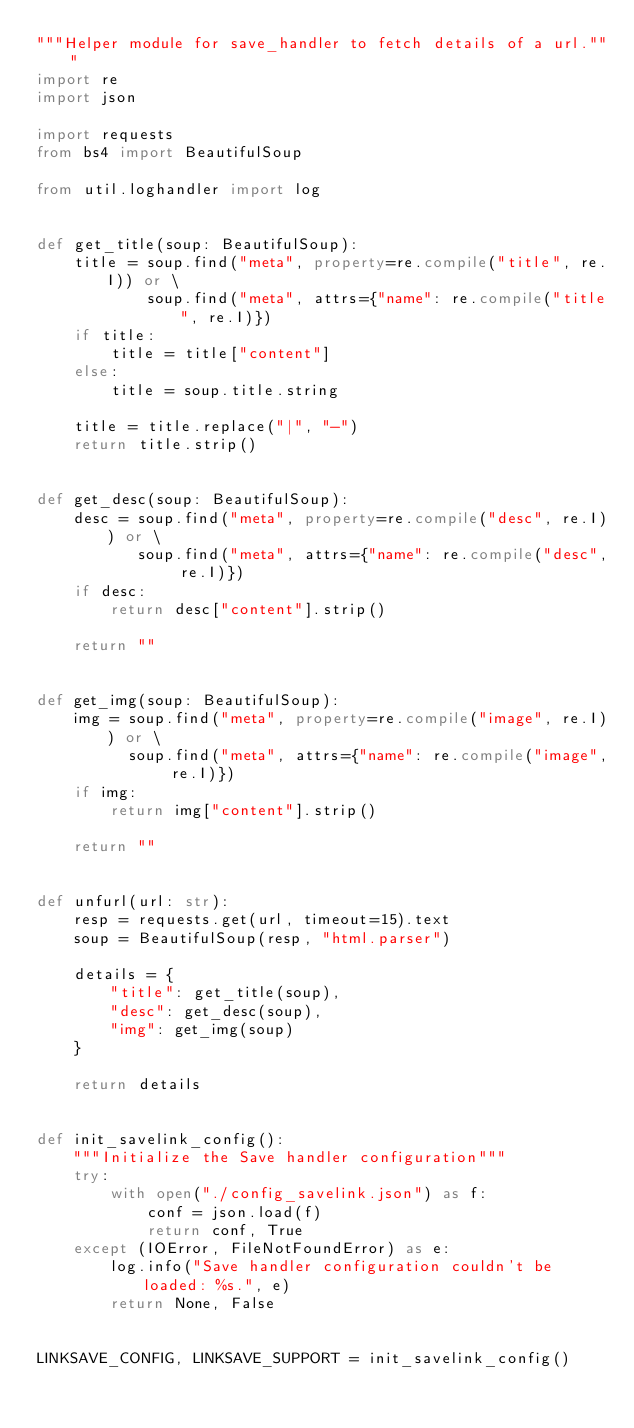Convert code to text. <code><loc_0><loc_0><loc_500><loc_500><_Python_>"""Helper module for save_handler to fetch details of a url."""
import re
import json

import requests
from bs4 import BeautifulSoup

from util.loghandler import log


def get_title(soup: BeautifulSoup):
    title = soup.find("meta", property=re.compile("title", re.I)) or \
            soup.find("meta", attrs={"name": re.compile("title", re.I)})
    if title:
        title = title["content"]
    else:
        title = soup.title.string

    title = title.replace("|", "-")
    return title.strip()


def get_desc(soup: BeautifulSoup):
    desc = soup.find("meta", property=re.compile("desc", re.I)) or \
           soup.find("meta", attrs={"name": re.compile("desc", re.I)})
    if desc:
        return desc["content"].strip()

    return ""


def get_img(soup: BeautifulSoup):
    img = soup.find("meta", property=re.compile("image", re.I)) or \
          soup.find("meta", attrs={"name": re.compile("image", re.I)})
    if img:
        return img["content"].strip()

    return ""


def unfurl(url: str):
    resp = requests.get(url, timeout=15).text
    soup = BeautifulSoup(resp, "html.parser")

    details = {
        "title": get_title(soup),
        "desc": get_desc(soup),
        "img": get_img(soup)
    }

    return details


def init_savelink_config():
    """Initialize the Save handler configuration"""
    try:
        with open("./config_savelink.json") as f:
            conf = json.load(f)
            return conf, True
    except (IOError, FileNotFoundError) as e:
        log.info("Save handler configuration couldn't be loaded: %s.", e)
        return None, False


LINKSAVE_CONFIG, LINKSAVE_SUPPORT = init_savelink_config()
</code> 